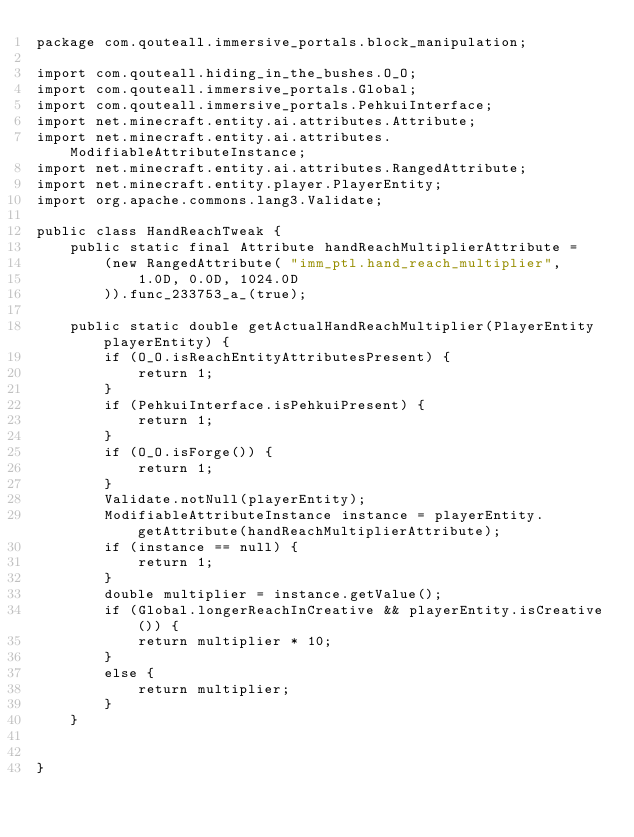<code> <loc_0><loc_0><loc_500><loc_500><_Java_>package com.qouteall.immersive_portals.block_manipulation;

import com.qouteall.hiding_in_the_bushes.O_O;
import com.qouteall.immersive_portals.Global;
import com.qouteall.immersive_portals.PehkuiInterface;
import net.minecraft.entity.ai.attributes.Attribute;
import net.minecraft.entity.ai.attributes.ModifiableAttributeInstance;
import net.minecraft.entity.ai.attributes.RangedAttribute;
import net.minecraft.entity.player.PlayerEntity;
import org.apache.commons.lang3.Validate;

public class HandReachTweak {
    public static final Attribute handReachMultiplierAttribute =
        (new RangedAttribute( "imm_ptl.hand_reach_multiplier",
            1.0D, 0.0D, 1024.0D
        )).func_233753_a_(true);
    
    public static double getActualHandReachMultiplier(PlayerEntity playerEntity) {
        if (O_O.isReachEntityAttributesPresent) {
            return 1;
        }
        if (PehkuiInterface.isPehkuiPresent) {
            return 1;
        }
        if (O_O.isForge()) {
            return 1;
        }
        Validate.notNull(playerEntity);
        ModifiableAttributeInstance instance = playerEntity.getAttribute(handReachMultiplierAttribute);
        if (instance == null) {
            return 1;
        }
        double multiplier = instance.getValue();
        if (Global.longerReachInCreative && playerEntity.isCreative()) {
            return multiplier * 10;
        }
        else {
            return multiplier;
        }
    }
    
    
}
</code> 